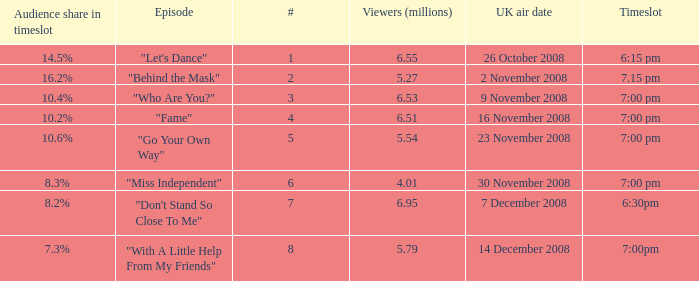Name the total number of timeslot for number 1 1.0. 